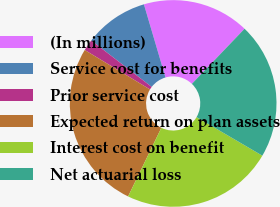<chart> <loc_0><loc_0><loc_500><loc_500><pie_chart><fcel>(In millions)<fcel>Service cost for benefits<fcel>Prior service cost<fcel>Expected return on plan assets<fcel>Interest cost on benefit<fcel>Net actuarial loss<nl><fcel>16.71%<fcel>10.0%<fcel>1.78%<fcel>26.47%<fcel>23.75%<fcel>21.29%<nl></chart> 